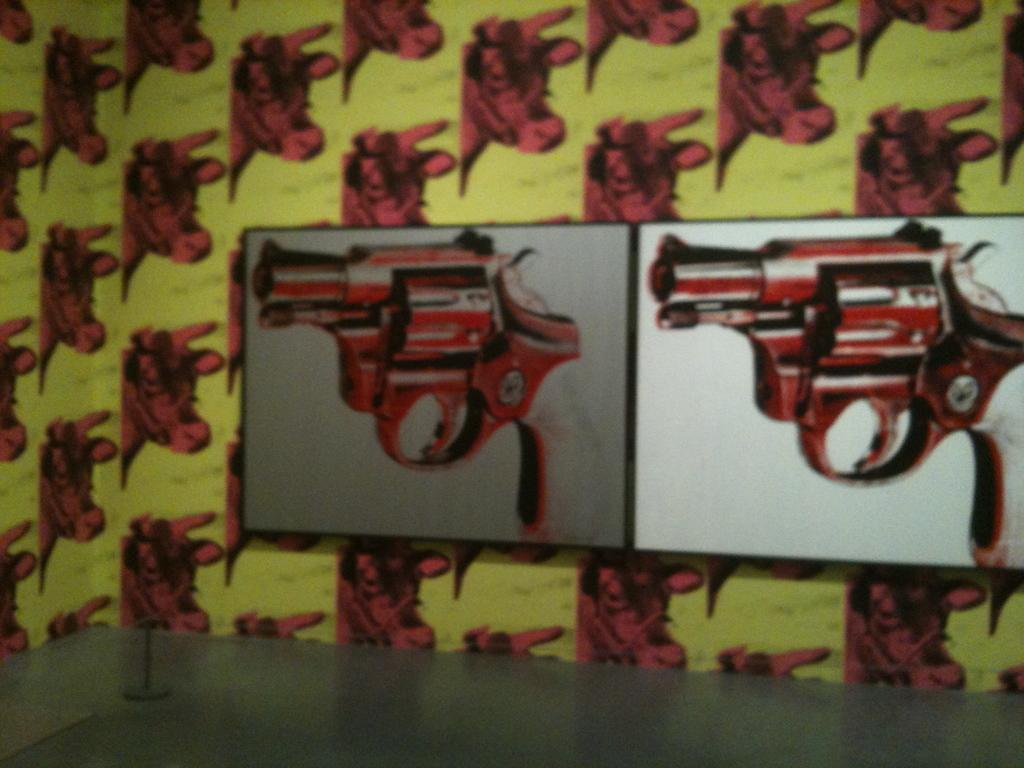What type of photos are hanging on the wall in the image? There are photos of guns on the wall in the image. Can you describe the object that is visible in the image? Unfortunately, there is not enough information provided to describe the object in the image. How many accounts does the sneeze have in the image? There is no sneeze present in the image, so it is not possible to determine how many accounts it might have. 